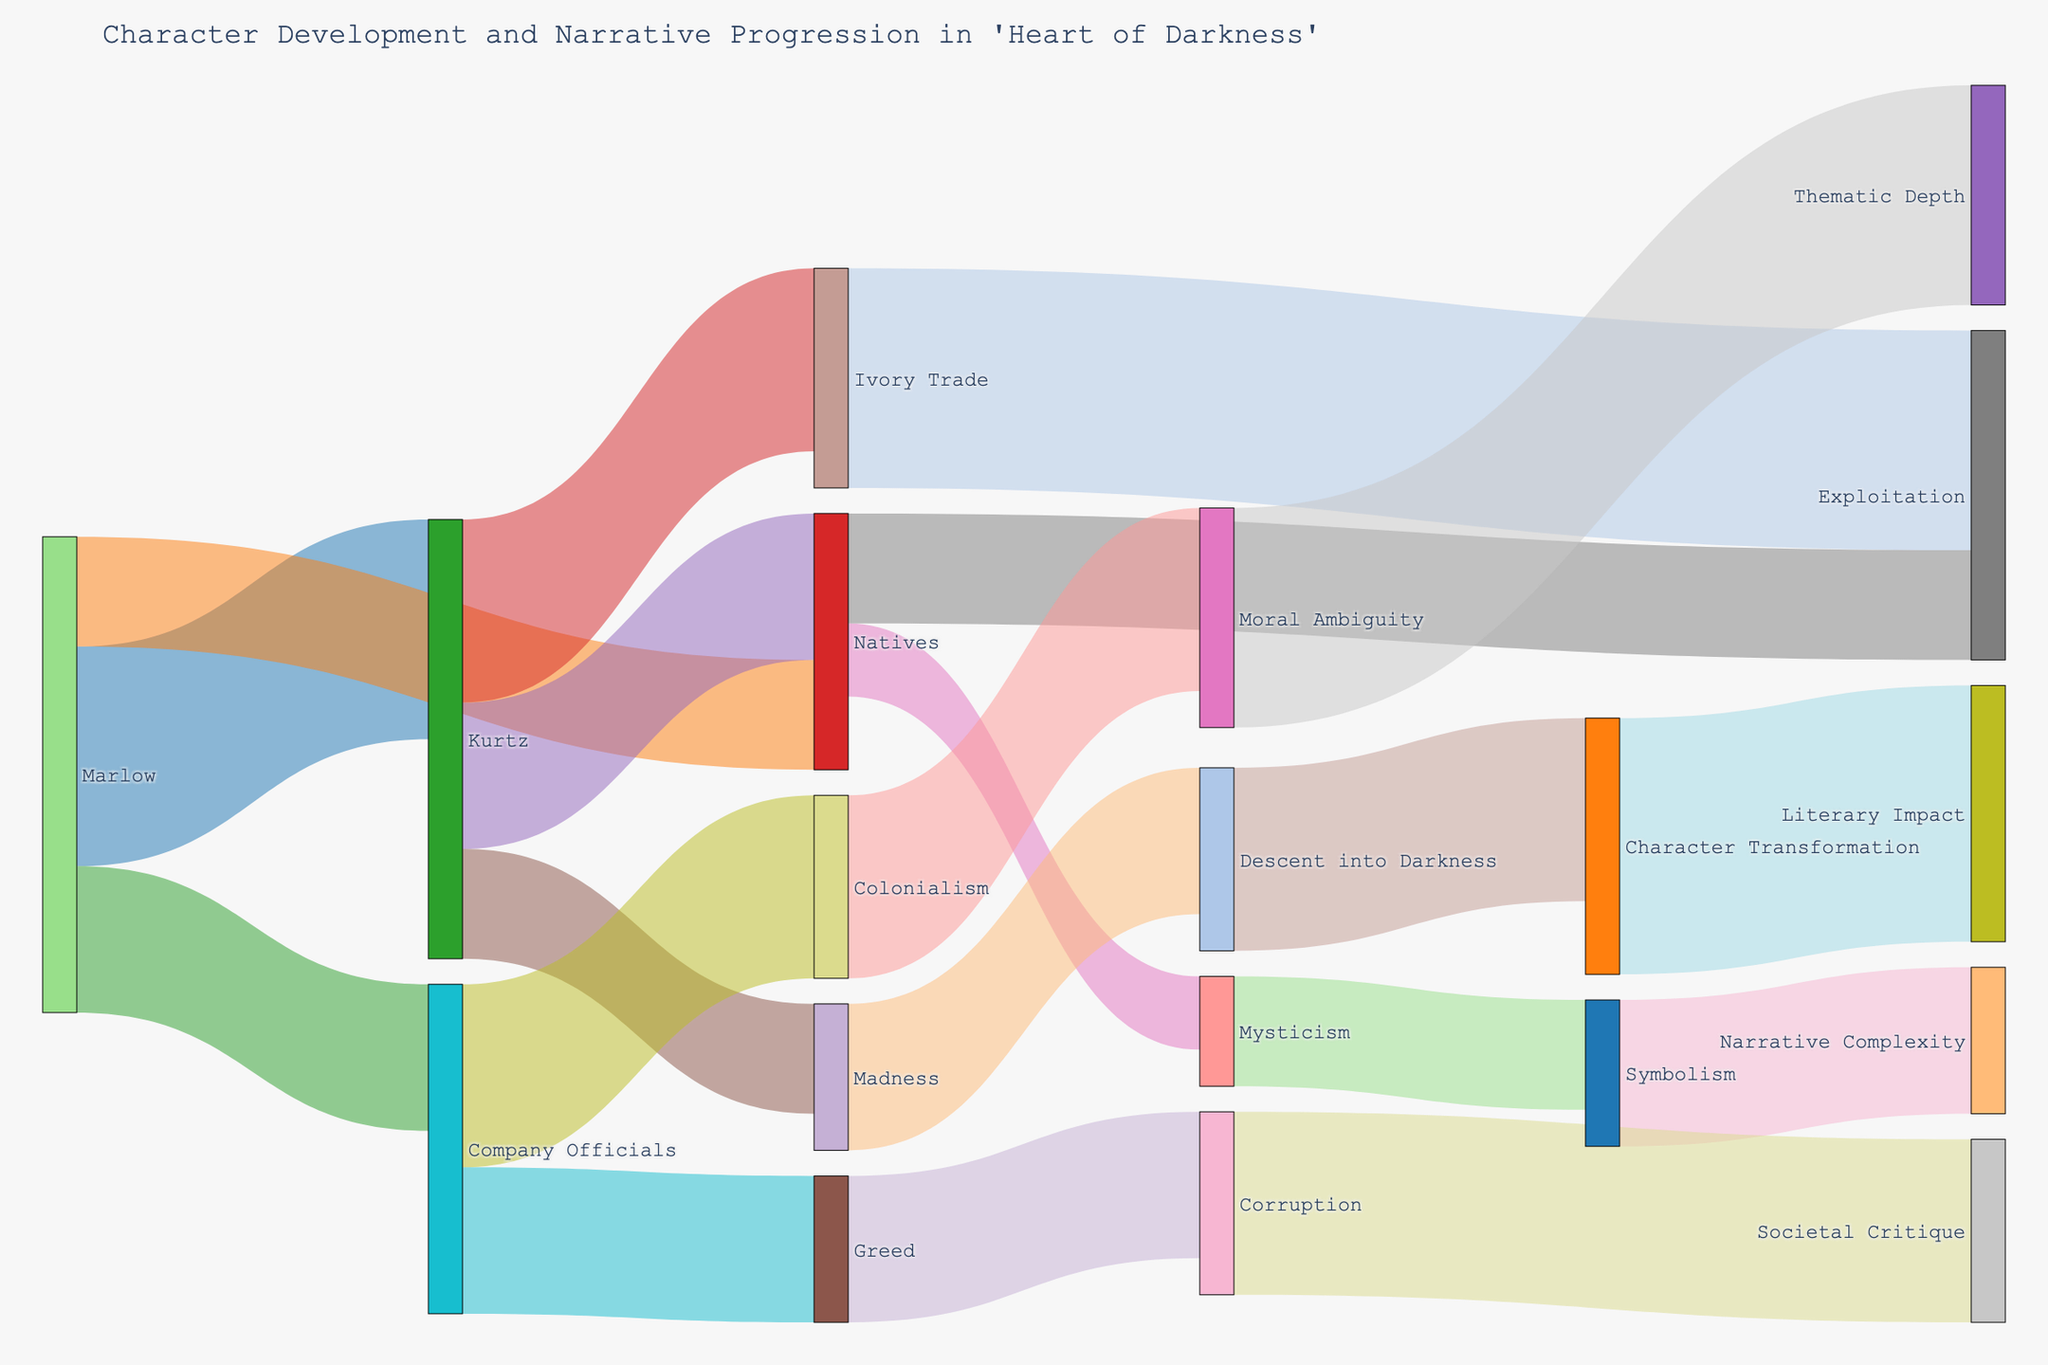What is the title of the figure? The title appears at the top of the figure, providing a summary of what the figure represents. Here, the title is "Character Development and Narrative Progression in 'Heart of Darkness'"
Answer: Character Development and Narrative Progression in 'Heart of Darkness' How many nodes are in the Sankey diagram? Counting all unique entities (both Source and Target) in the figure gives the number of nodes. In this case, there are 19 nodes in total.
Answer: 19 Which nodes are directly connected to Marlow? By following the links originating from Marlow, we find he connects to Kurtz, Natives, and Company Officials.
Answer: Kurtz, Natives, Company Officials What is the value associated with the link between Kurtz and Madness? Checking the value corresponding to the link from Kurtz to Madness shows it's 15.
Answer: 15 Which node has the highest total value of outgoing links? Summing the values of outgoing links for each node shows Kurtz has the highest total with links to Ivory Trade (25), Natives (20), and Madness (15), summing up to 60.
Answer: Kurtz What is the combined value of links leading to Exploitation? Adding the values of links from Natives (15) and Ivory Trade (30) to Exploitation gives a combined value of 45.
Answer: 45 Compare the values of links between Natives and Mysticism versus Natives and Exploitation. Which one is higher? The link from Natives to Mysticism has a value of 10, while the link to Exploitation has a value of 15. So, the link to Exploitation is higher.
Answer: Natives to Exploitation What can be inferred about the significance of the link between Descent into Darkness and Character Transformation in terms of value? The value of 25 for this link indicates a substantial contribution, suggesting an essential narrative aspect where a descent into darkness leads significantly to character transformation.
Answer: Significant How does Colonialism relate to Moral Ambiguity and Greed based on the diagram? Following the links from Company Officials to Colonialism (25) and Greed (20) and then from Colonialism to Moral Ambiguity (25) shows Colonialism’s complexity, connecting moral themes and greed.
Answer: Related through complexity Identify and explain the nodes that contribute to the thematic depth of 'Heart of Darkness'. Tracing links to Thematic Depth, we see it arises from Moral Ambiguity (30), which in turn follows from Colonialism (25), originating from Company Officials (20). This path reflects the intricate narrative layers of the story.
Answer: Company Officials, Colonialism, Moral Ambiguity 